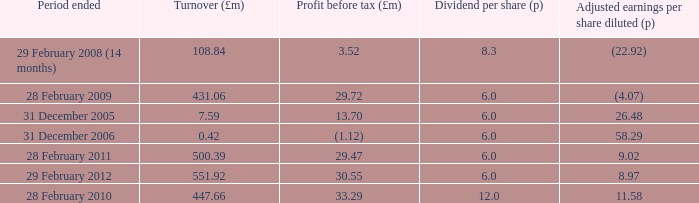How many items appear in the dividend per share when the turnover is 0.42? 1.0. 